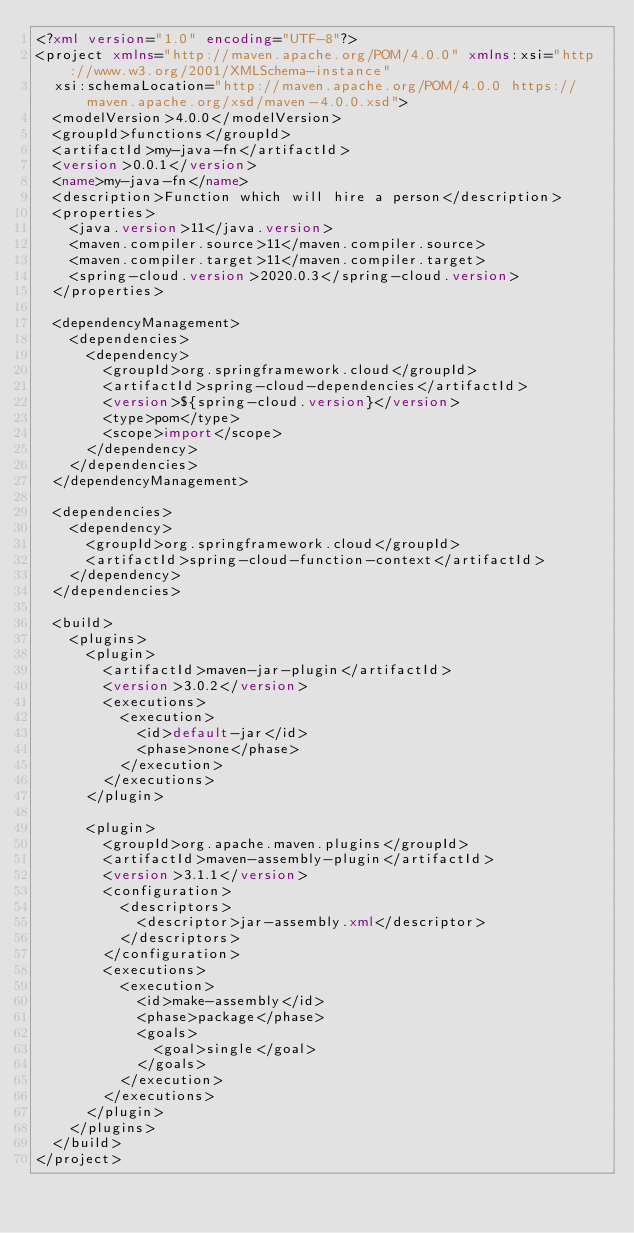Convert code to text. <code><loc_0><loc_0><loc_500><loc_500><_XML_><?xml version="1.0" encoding="UTF-8"?>
<project xmlns="http://maven.apache.org/POM/4.0.0" xmlns:xsi="http://www.w3.org/2001/XMLSchema-instance"
	xsi:schemaLocation="http://maven.apache.org/POM/4.0.0 https://maven.apache.org/xsd/maven-4.0.0.xsd">
	<modelVersion>4.0.0</modelVersion>
	<groupId>functions</groupId>
	<artifactId>my-java-fn</artifactId>
	<version>0.0.1</version>
	<name>my-java-fn</name>
	<description>Function which will hire a person</description>
	<properties>
		<java.version>11</java.version>
		<maven.compiler.source>11</maven.compiler.source>
		<maven.compiler.target>11</maven.compiler.target>
		<spring-cloud.version>2020.0.3</spring-cloud.version>
	</properties>

	<dependencyManagement>
		<dependencies>
			<dependency>
				<groupId>org.springframework.cloud</groupId>
				<artifactId>spring-cloud-dependencies</artifactId>
				<version>${spring-cloud.version}</version>
				<type>pom</type>
				<scope>import</scope>
			</dependency>
		</dependencies>
	</dependencyManagement>

	<dependencies>
		<dependency>
			<groupId>org.springframework.cloud</groupId>
			<artifactId>spring-cloud-function-context</artifactId>
		</dependency>
	</dependencies>

	<build>
		<plugins>
			<plugin>
				<artifactId>maven-jar-plugin</artifactId>
				<version>3.0.2</version>
				<executions>
					<execution>
						<id>default-jar</id>
						<phase>none</phase>
					</execution>
				</executions>
			</plugin>

			<plugin>
				<groupId>org.apache.maven.plugins</groupId>
				<artifactId>maven-assembly-plugin</artifactId>
				<version>3.1.1</version>
				<configuration>
					<descriptors>
						<descriptor>jar-assembly.xml</descriptor>
					</descriptors>
				</configuration>
				<executions>
					<execution>
						<id>make-assembly</id>
						<phase>package</phase>
						<goals>
							<goal>single</goal>
						</goals>
					</execution>
				</executions>
			</plugin>
		</plugins>
	</build>
</project>
</code> 